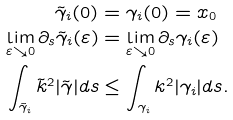Convert formula to latex. <formula><loc_0><loc_0><loc_500><loc_500>\tilde { \gamma } _ { i } ( 0 ) & = \gamma _ { i } ( 0 ) = x _ { 0 } \\ \lim _ { \varepsilon \searrow 0 } \partial _ { s } \tilde { \gamma } _ { i } ( \varepsilon ) & = \lim _ { \varepsilon \searrow 0 } \partial _ { s } \gamma _ { i } ( \varepsilon ) \\ \int _ { \tilde { \gamma } _ { i } } \tilde { k } ^ { 2 } | \tilde { \gamma } | d s & \leq \int _ { \gamma _ { i } } k ^ { 2 } | \gamma _ { i } | d s .</formula> 